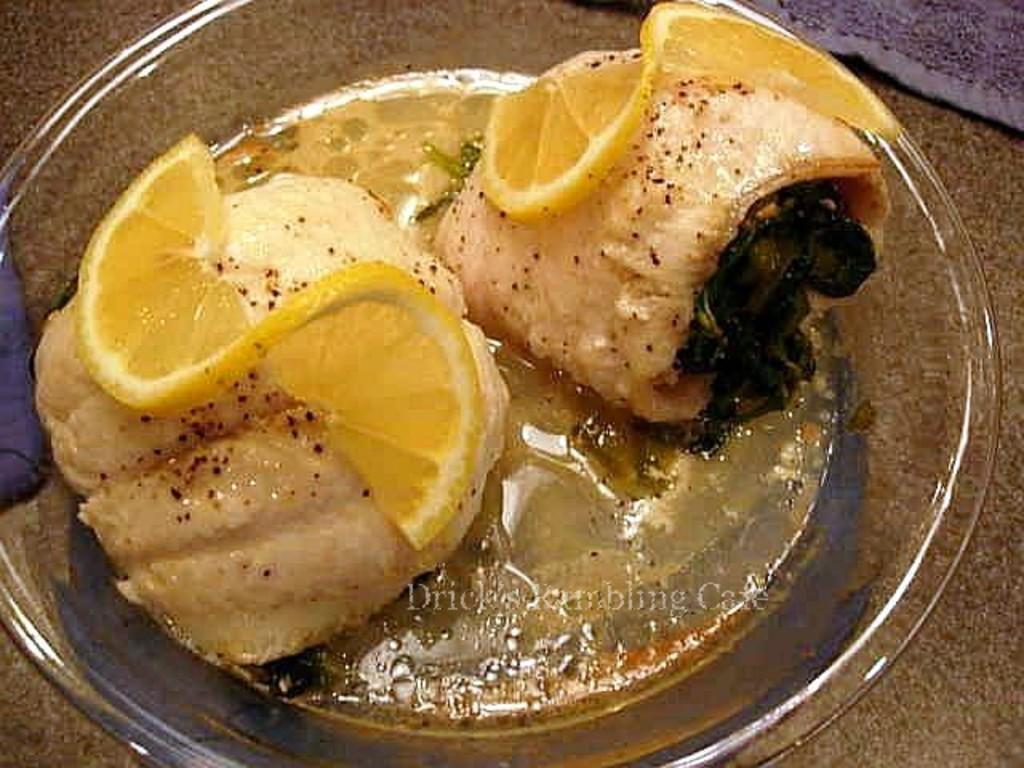What type of container is used to serve the food item in the image? The food item is served in a glass bowl in the image. What else can be seen beside the bowl in the image? There is a cloth beside the bowl in the image. What type of beef is being served in the quince-flavored dish in the image? There is no beef or quince mentioned in the image, and the food item served in the glass bowl is not described in detail. 